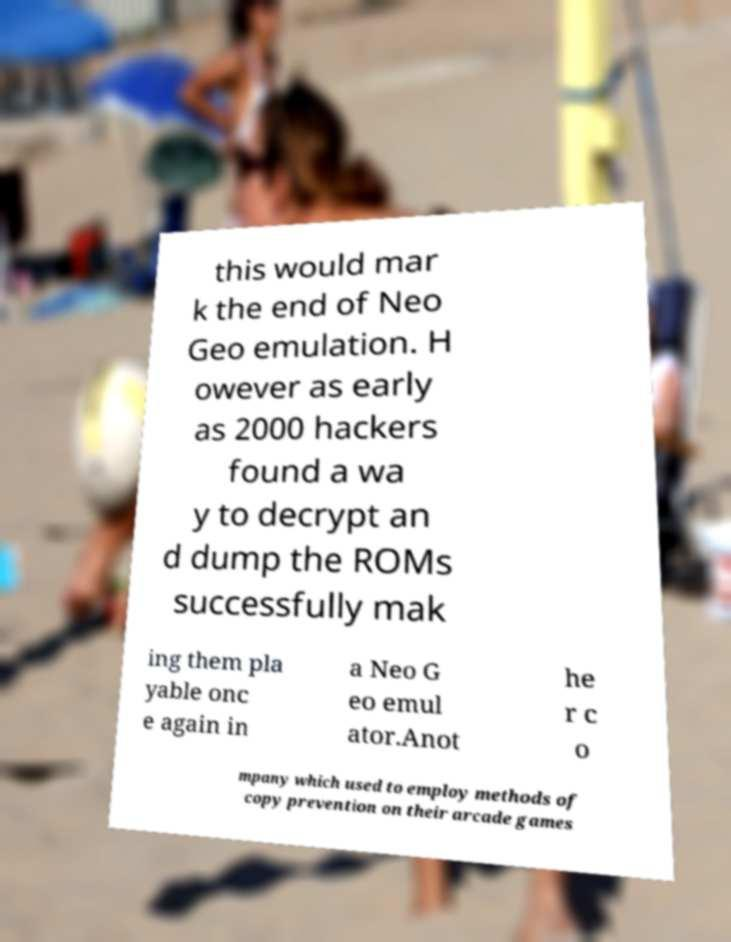Could you assist in decoding the text presented in this image and type it out clearly? this would mar k the end of Neo Geo emulation. H owever as early as 2000 hackers found a wa y to decrypt an d dump the ROMs successfully mak ing them pla yable onc e again in a Neo G eo emul ator.Anot he r c o mpany which used to employ methods of copy prevention on their arcade games 